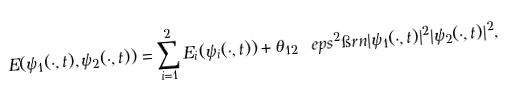<formula> <loc_0><loc_0><loc_500><loc_500>E ( \psi _ { 1 } ( \cdot , t ) , \psi _ { 2 } ( \cdot , t ) ) = \sum _ { i = 1 } ^ { 2 } E _ { i } ( \psi _ { i } ( \cdot , t ) ) + \theta _ { 1 2 } \ e p s ^ { 2 } \i r n | \psi _ { 1 } ( \cdot , t ) | ^ { 2 } | \psi _ { 2 } ( \cdot , t ) | ^ { 2 } ,</formula> 